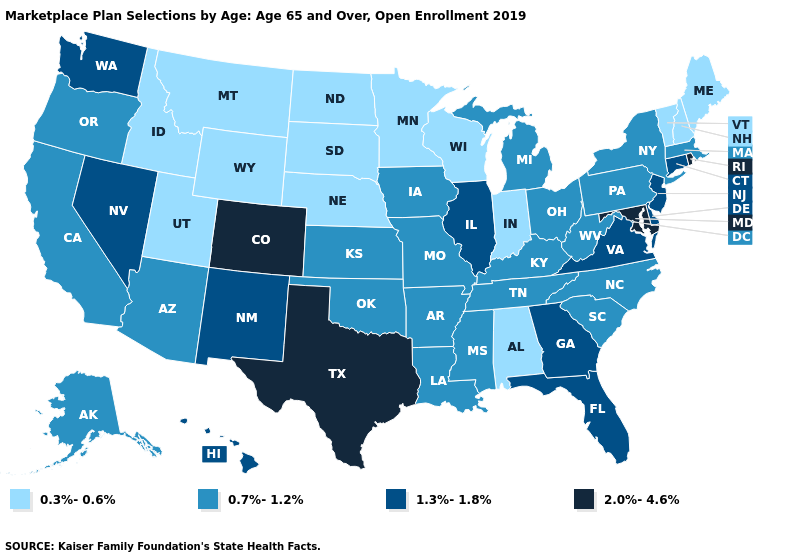Name the states that have a value in the range 2.0%-4.6%?
Write a very short answer. Colorado, Maryland, Rhode Island, Texas. What is the value of Illinois?
Write a very short answer. 1.3%-1.8%. Name the states that have a value in the range 0.3%-0.6%?
Be succinct. Alabama, Idaho, Indiana, Maine, Minnesota, Montana, Nebraska, New Hampshire, North Dakota, South Dakota, Utah, Vermont, Wisconsin, Wyoming. Name the states that have a value in the range 2.0%-4.6%?
Write a very short answer. Colorado, Maryland, Rhode Island, Texas. Name the states that have a value in the range 0.3%-0.6%?
Give a very brief answer. Alabama, Idaho, Indiana, Maine, Minnesota, Montana, Nebraska, New Hampshire, North Dakota, South Dakota, Utah, Vermont, Wisconsin, Wyoming. Name the states that have a value in the range 2.0%-4.6%?
Give a very brief answer. Colorado, Maryland, Rhode Island, Texas. Which states have the lowest value in the Northeast?
Answer briefly. Maine, New Hampshire, Vermont. Does Nevada have a lower value than Alabama?
Be succinct. No. Among the states that border California , which have the lowest value?
Keep it brief. Arizona, Oregon. Which states have the lowest value in the MidWest?
Answer briefly. Indiana, Minnesota, Nebraska, North Dakota, South Dakota, Wisconsin. Among the states that border Iowa , which have the lowest value?
Quick response, please. Minnesota, Nebraska, South Dakota, Wisconsin. Name the states that have a value in the range 2.0%-4.6%?
Quick response, please. Colorado, Maryland, Rhode Island, Texas. Name the states that have a value in the range 1.3%-1.8%?
Keep it brief. Connecticut, Delaware, Florida, Georgia, Hawaii, Illinois, Nevada, New Jersey, New Mexico, Virginia, Washington. What is the lowest value in the West?
Quick response, please. 0.3%-0.6%. 